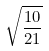<formula> <loc_0><loc_0><loc_500><loc_500>\sqrt { \frac { 1 0 } { 2 1 } }</formula> 